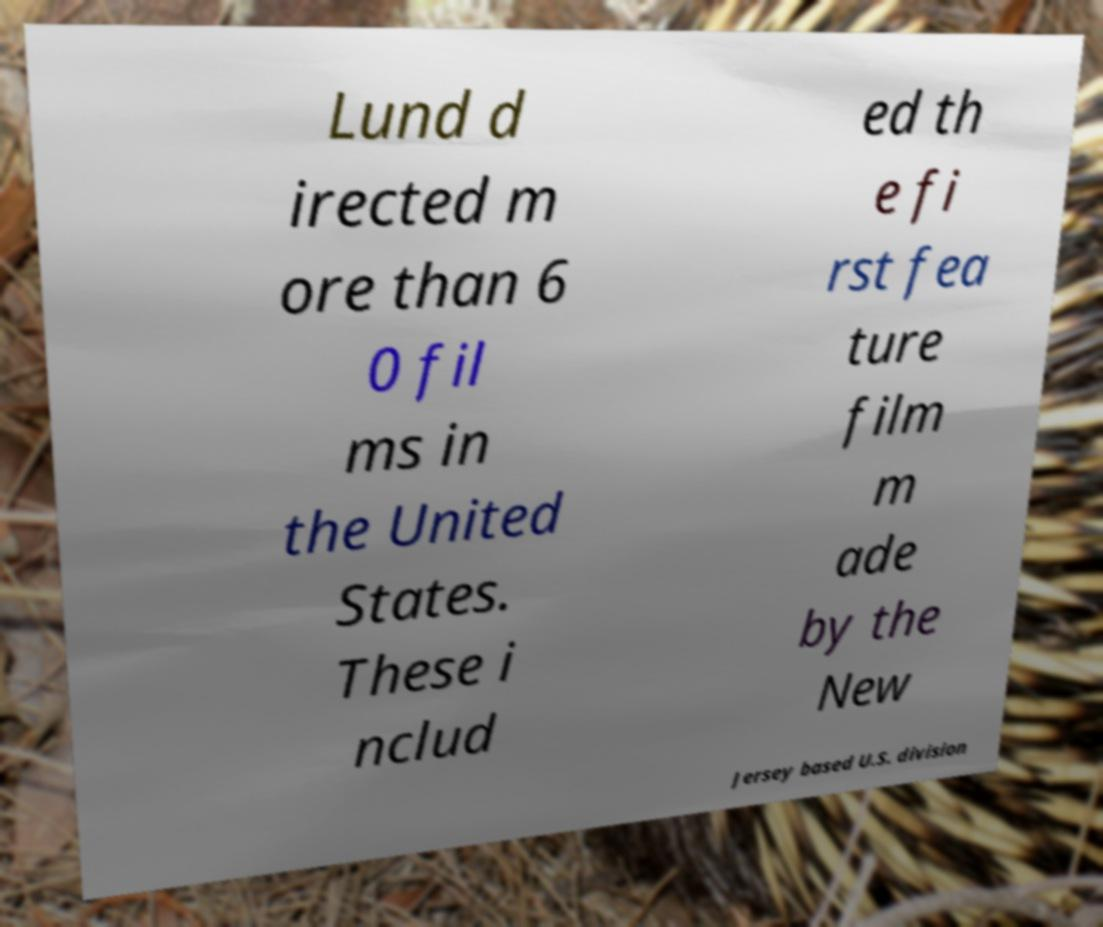Please identify and transcribe the text found in this image. Lund d irected m ore than 6 0 fil ms in the United States. These i nclud ed th e fi rst fea ture film m ade by the New Jersey based U.S. division 